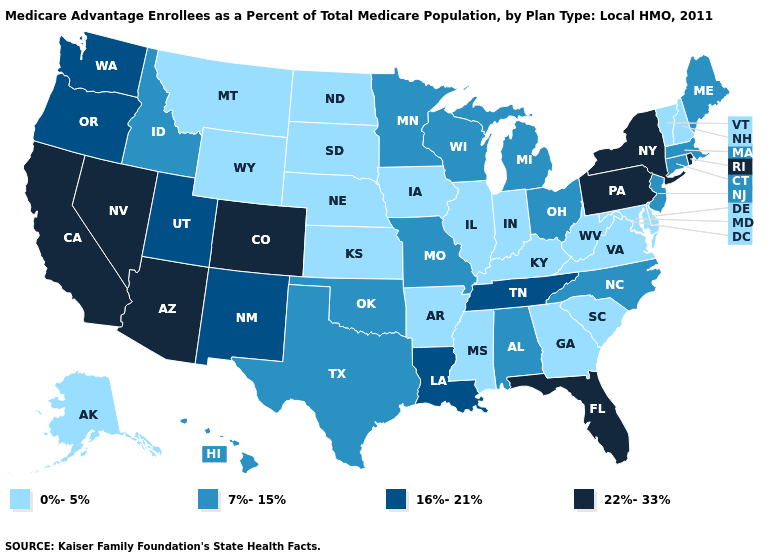Name the states that have a value in the range 16%-21%?
Be succinct. Louisiana, New Mexico, Oregon, Tennessee, Utah, Washington. What is the highest value in the South ?
Give a very brief answer. 22%-33%. What is the value of Kansas?
Quick response, please. 0%-5%. Which states have the lowest value in the USA?
Answer briefly. Alaska, Arkansas, Delaware, Georgia, Iowa, Illinois, Indiana, Kansas, Kentucky, Maryland, Mississippi, Montana, North Dakota, Nebraska, New Hampshire, South Carolina, South Dakota, Virginia, Vermont, West Virginia, Wyoming. Does Illinois have a lower value than Virginia?
Keep it brief. No. Name the states that have a value in the range 16%-21%?
Answer briefly. Louisiana, New Mexico, Oregon, Tennessee, Utah, Washington. What is the value of Pennsylvania?
Keep it brief. 22%-33%. What is the value of Georgia?
Answer briefly. 0%-5%. Which states have the lowest value in the USA?
Write a very short answer. Alaska, Arkansas, Delaware, Georgia, Iowa, Illinois, Indiana, Kansas, Kentucky, Maryland, Mississippi, Montana, North Dakota, Nebraska, New Hampshire, South Carolina, South Dakota, Virginia, Vermont, West Virginia, Wyoming. Name the states that have a value in the range 16%-21%?
Answer briefly. Louisiana, New Mexico, Oregon, Tennessee, Utah, Washington. Does Virginia have a lower value than New Hampshire?
Write a very short answer. No. Is the legend a continuous bar?
Give a very brief answer. No. Which states have the lowest value in the USA?
Be succinct. Alaska, Arkansas, Delaware, Georgia, Iowa, Illinois, Indiana, Kansas, Kentucky, Maryland, Mississippi, Montana, North Dakota, Nebraska, New Hampshire, South Carolina, South Dakota, Virginia, Vermont, West Virginia, Wyoming. What is the highest value in the USA?
Keep it brief. 22%-33%. Among the states that border Indiana , does Illinois have the lowest value?
Concise answer only. Yes. 